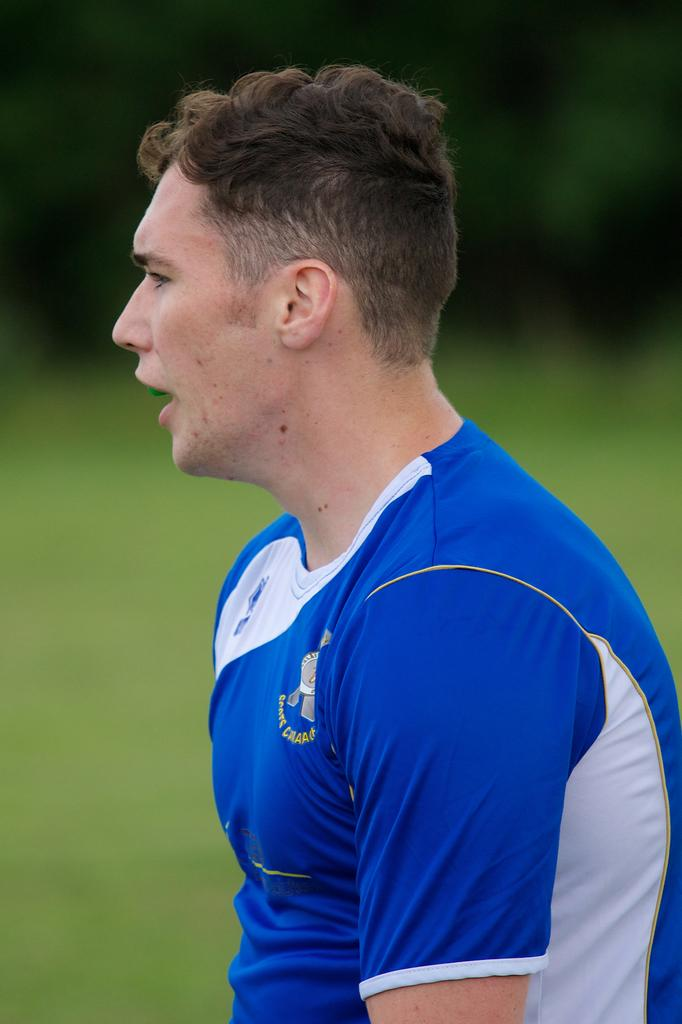What can be seen in the image? There is a person in the image. What is the person wearing? The person is wearing a uniform. Can you describe the background of the image? The background of the image is blurry. How many socks can be seen in the image? There are no socks visible in the image. What type of parcel is being delivered by the person in the image? There is no parcel present in the image. 